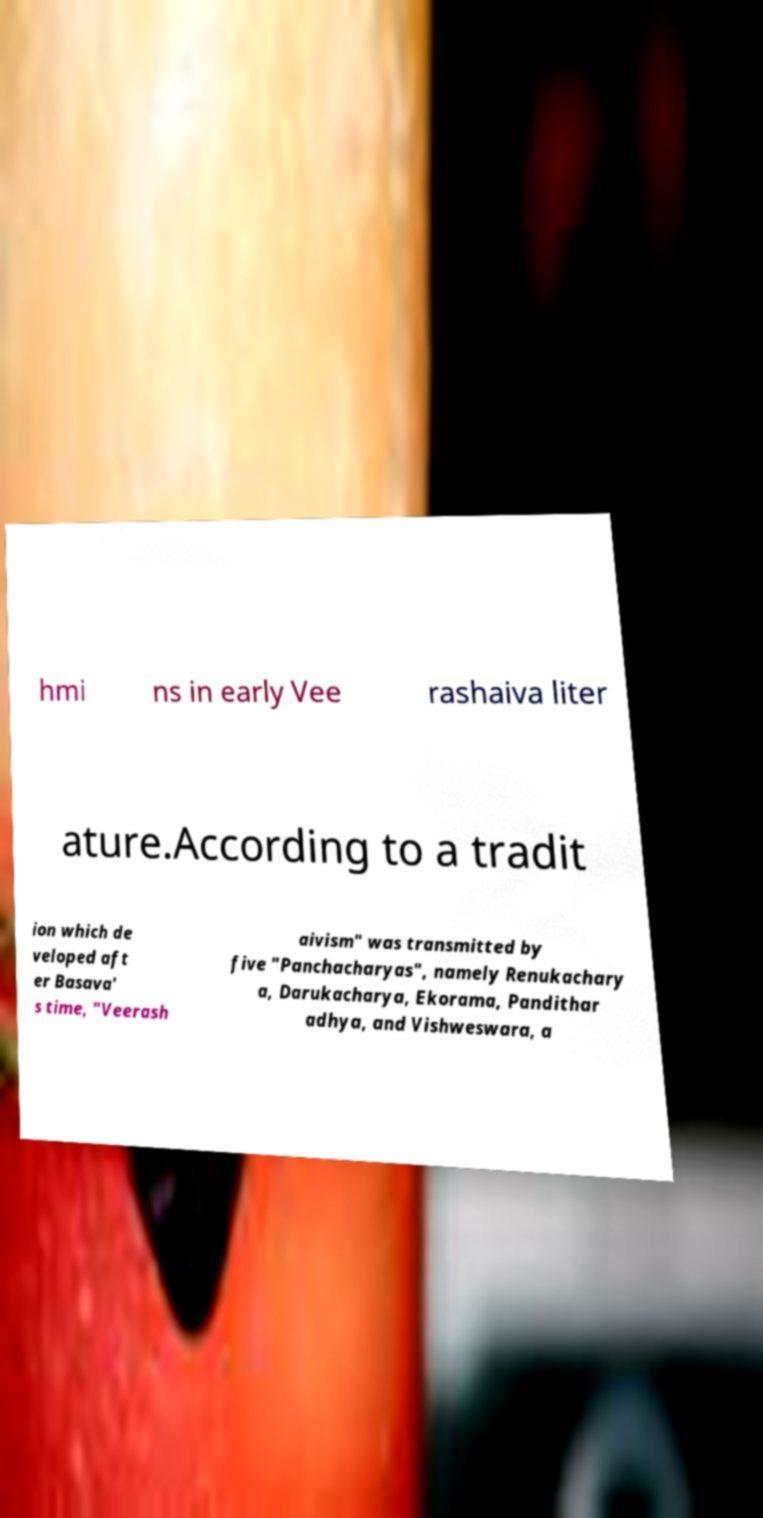Could you extract and type out the text from this image? hmi ns in early Vee rashaiva liter ature.According to a tradit ion which de veloped aft er Basava' s time, "Veerash aivism" was transmitted by five "Panchacharyas", namely Renukachary a, Darukacharya, Ekorama, Pandithar adhya, and Vishweswara, a 